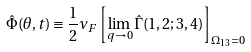<formula> <loc_0><loc_0><loc_500><loc_500>\hat { \Phi } ( \theta , t ) \equiv \frac { 1 } { 2 } \nu _ { F } \left [ \lim _ { { q } \to 0 } { \hat { \Gamma } } ( { 1 } , { 2 } ; { 3 } , { 4 } ) \right ] _ { \Omega _ { 1 3 } = 0 }</formula> 